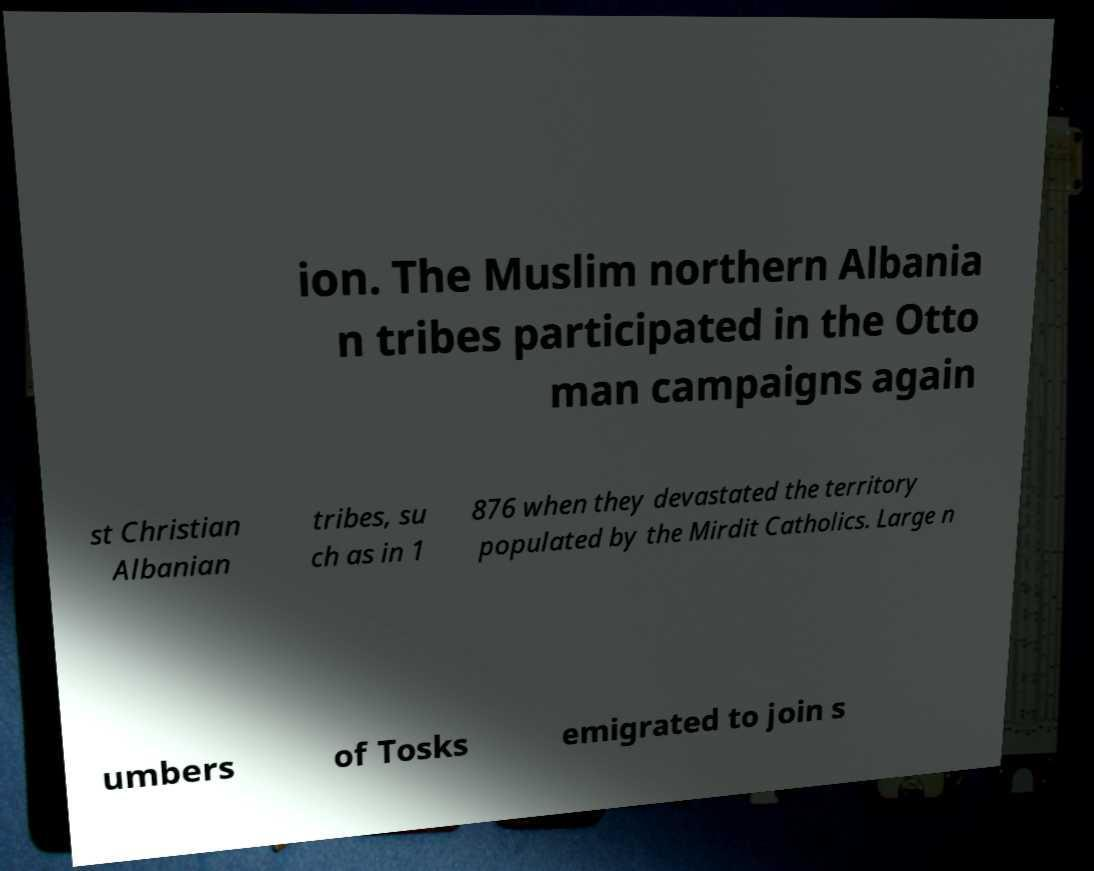Could you extract and type out the text from this image? ion. The Muslim northern Albania n tribes participated in the Otto man campaigns again st Christian Albanian tribes, su ch as in 1 876 when they devastated the territory populated by the Mirdit Catholics. Large n umbers of Tosks emigrated to join s 